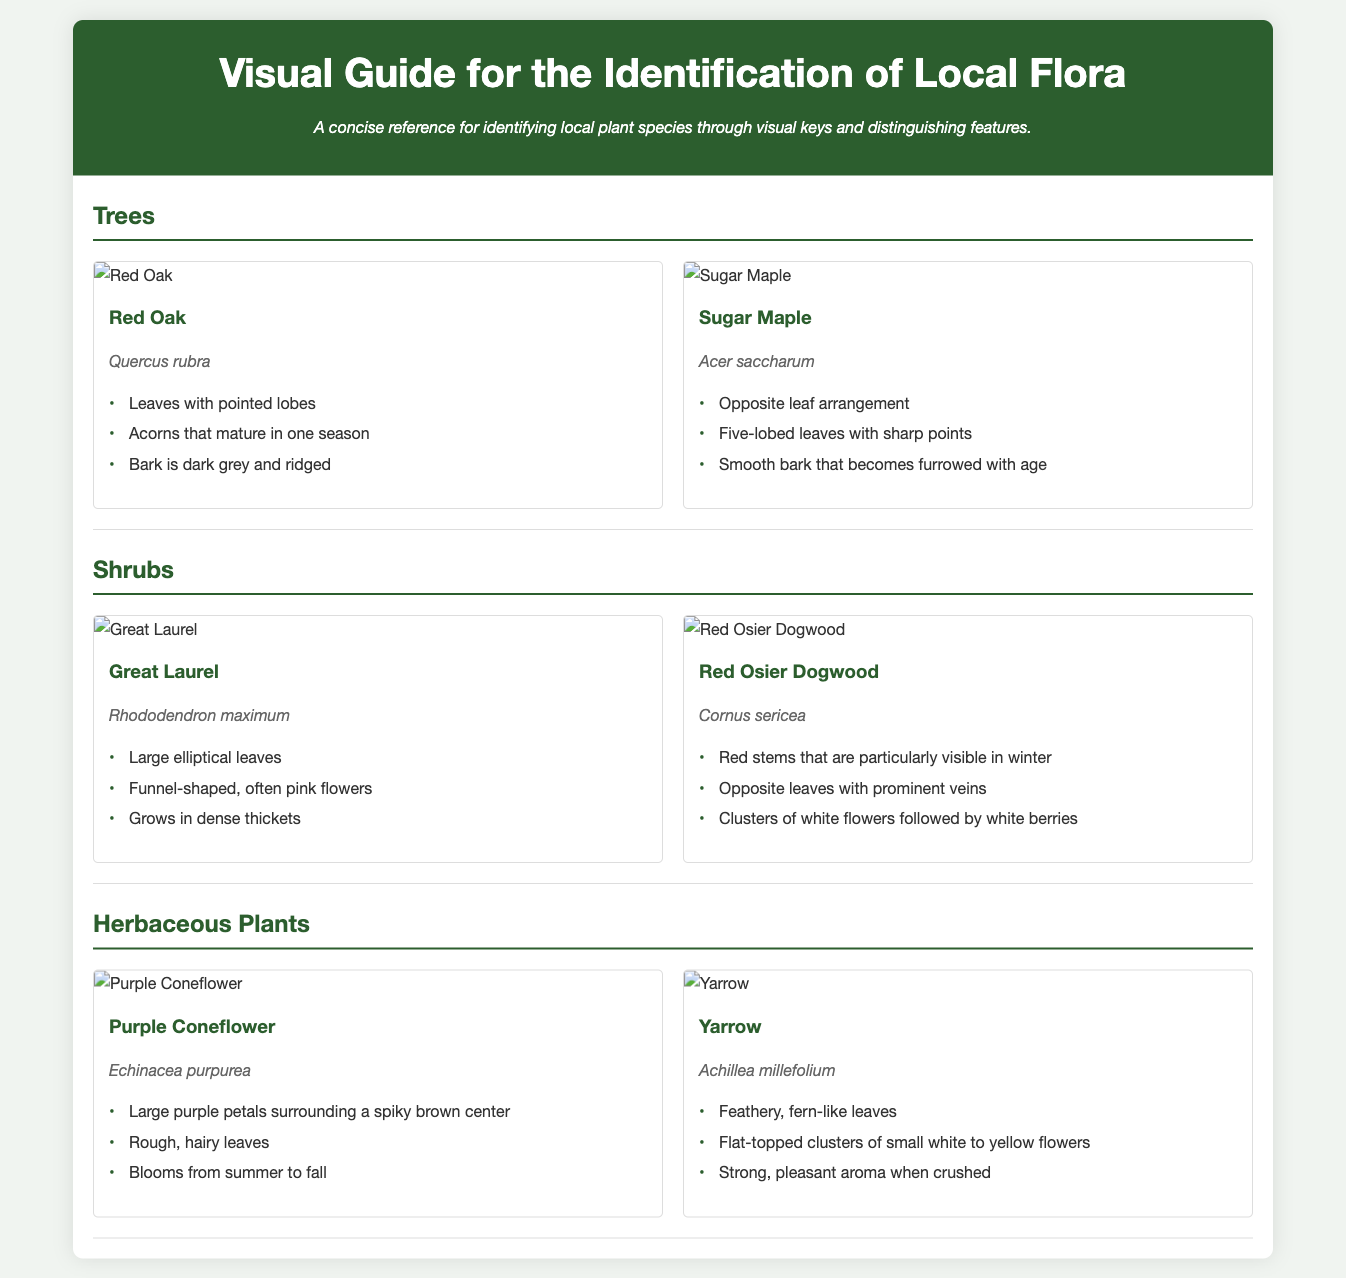What is the title of the document? The title is prominently displayed at the top of the document and serves as the main heading.
Answer: Visual Guide for the Identification of Local Flora How many tree species are listed? The number of species listed in the "Trees" section indicates the total count for that category.
Answer: 2 What is the scientific name of the Purple Coneflower? The scientific name is found below the common name in the herbaceous plants section.
Answer: Echinacea purpurea What type of arrangement do Sugar Maple leaves have? The specific leaf arrangement is mentioned in the species card for Sugar Maple.
Answer: Opposite Which shrub has red stems visible in winter? The characteristic feature of red stems in winter is mentioned under the Red Osier Dogwood.
Answer: Red Osier Dogwood How many lobes do the leaves of Sugar Maple have? The number of lobes of the leaves is detailed in the description of that plant species.
Answer: Five What color are the flowers of the Great Laurel? The color of the flowers is mentioned in the description of the Great Laurel species.
Answer: Pink What is the distinguishing feature of Yarrow's leaves? The texture and appearance of Yarrow's leaves is described in its species card.
Answer: Fern-like 